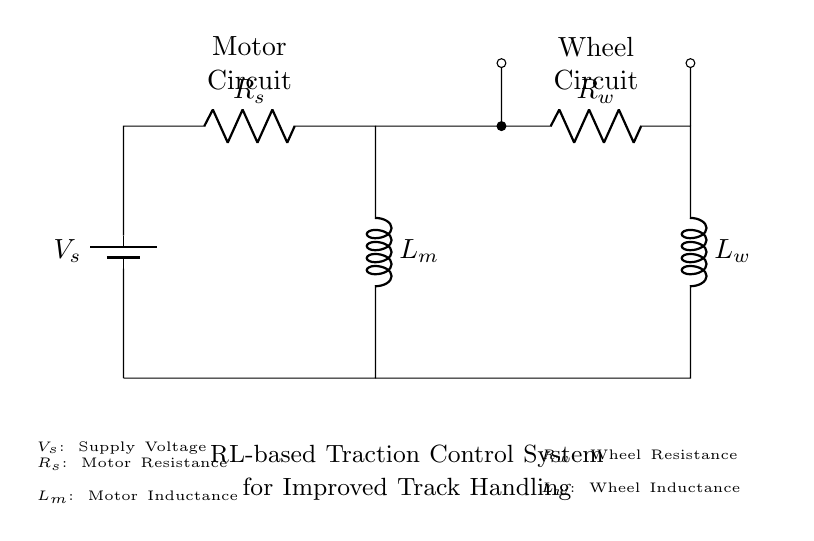What is the supply voltage in this circuit? The supply voltage is represented by \( V_{s} \), which is the voltage source shown at the top left of the circuit diagram.
Answer: V_{s} What components make up the motor circuit? The motor circuit consists of the components \( R_{s} \) and \( L_{m} \), which are connected in series with the supply voltage \( V_{s} \) and form a loop.
Answer: R_{s}, L_{m} What type of inductance is used in the wheel circuit? The inductance in the wheel circuit is \( L_{w} \), which is specified next to the wheel resistance \( R_{w} \).
Answer: L_{w} Which two components are in series in the wheel circuit? In the wheel circuit, the components that are in series include \( R_{w} \) and \( L_{w} \), shown connected one after the other leading to the ground.
Answer: R_{w}, L_{w} What is the relationship between \( R_{s} \) and \( R_{w} \) in terms of circuit function? Both \( R_{s} \) and \( R_{w} \) represent resistances in their respective circuits, affecting the overall current flow and energy dissipation in the system, with different roles in driving the motor and wheels.
Answer: Resistance How does the inductance of \( L_{m} \) impact the circuit's performance during acceleration? The inductance \( L_{m} \) in the motor circuit allows it to oppose changes in current, contributing to smoother acceleration and stability, which is crucial for traction control in various track conditions.
Answer: Smoother acceleration Does the circuit have a feedback mechanism for traction control? The diagram does not explicitly depict a feedback mechanism, as it focuses on the motor and wheel resistances and inductances; however, a traction control system would typically require additional components for real-time feedback.
Answer: No 